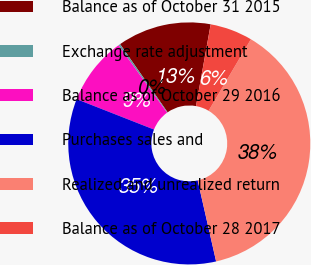Convert chart. <chart><loc_0><loc_0><loc_500><loc_500><pie_chart><fcel>Balance as of October 31 2015<fcel>Exchange rate adjustment<fcel>Balance as of October 29 2016<fcel>Purchases sales and<fcel>Realized and unrealized return<fcel>Balance as of October 28 2017<nl><fcel>12.52%<fcel>0.25%<fcel>9.1%<fcel>34.52%<fcel>37.94%<fcel>5.67%<nl></chart> 